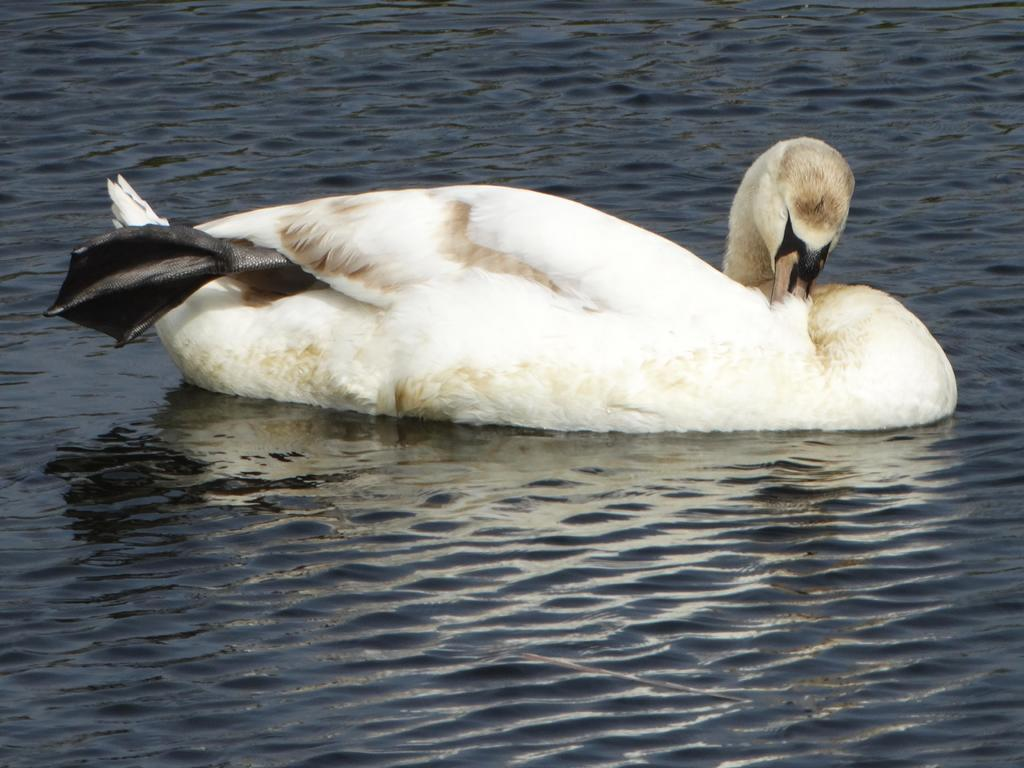What is the primary element visible in the image? There is water in the image. What type of animal can be seen in the water? There is a white-colored swan in the water. What type of plantation can be seen in the image? There is no plantation present in the image; it features water and a swan. How does the swan look at the viewer in the image? The image does not show the swan looking at the viewer, as it is a still image and does not depict any movement or interaction with the viewer. 